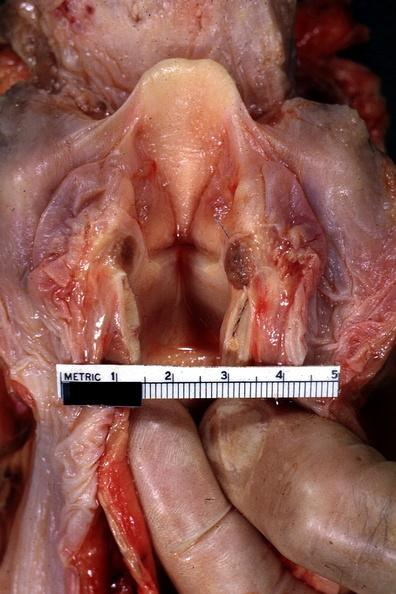does opened larynx show quite well?
Answer the question using a single word or phrase. Yes 